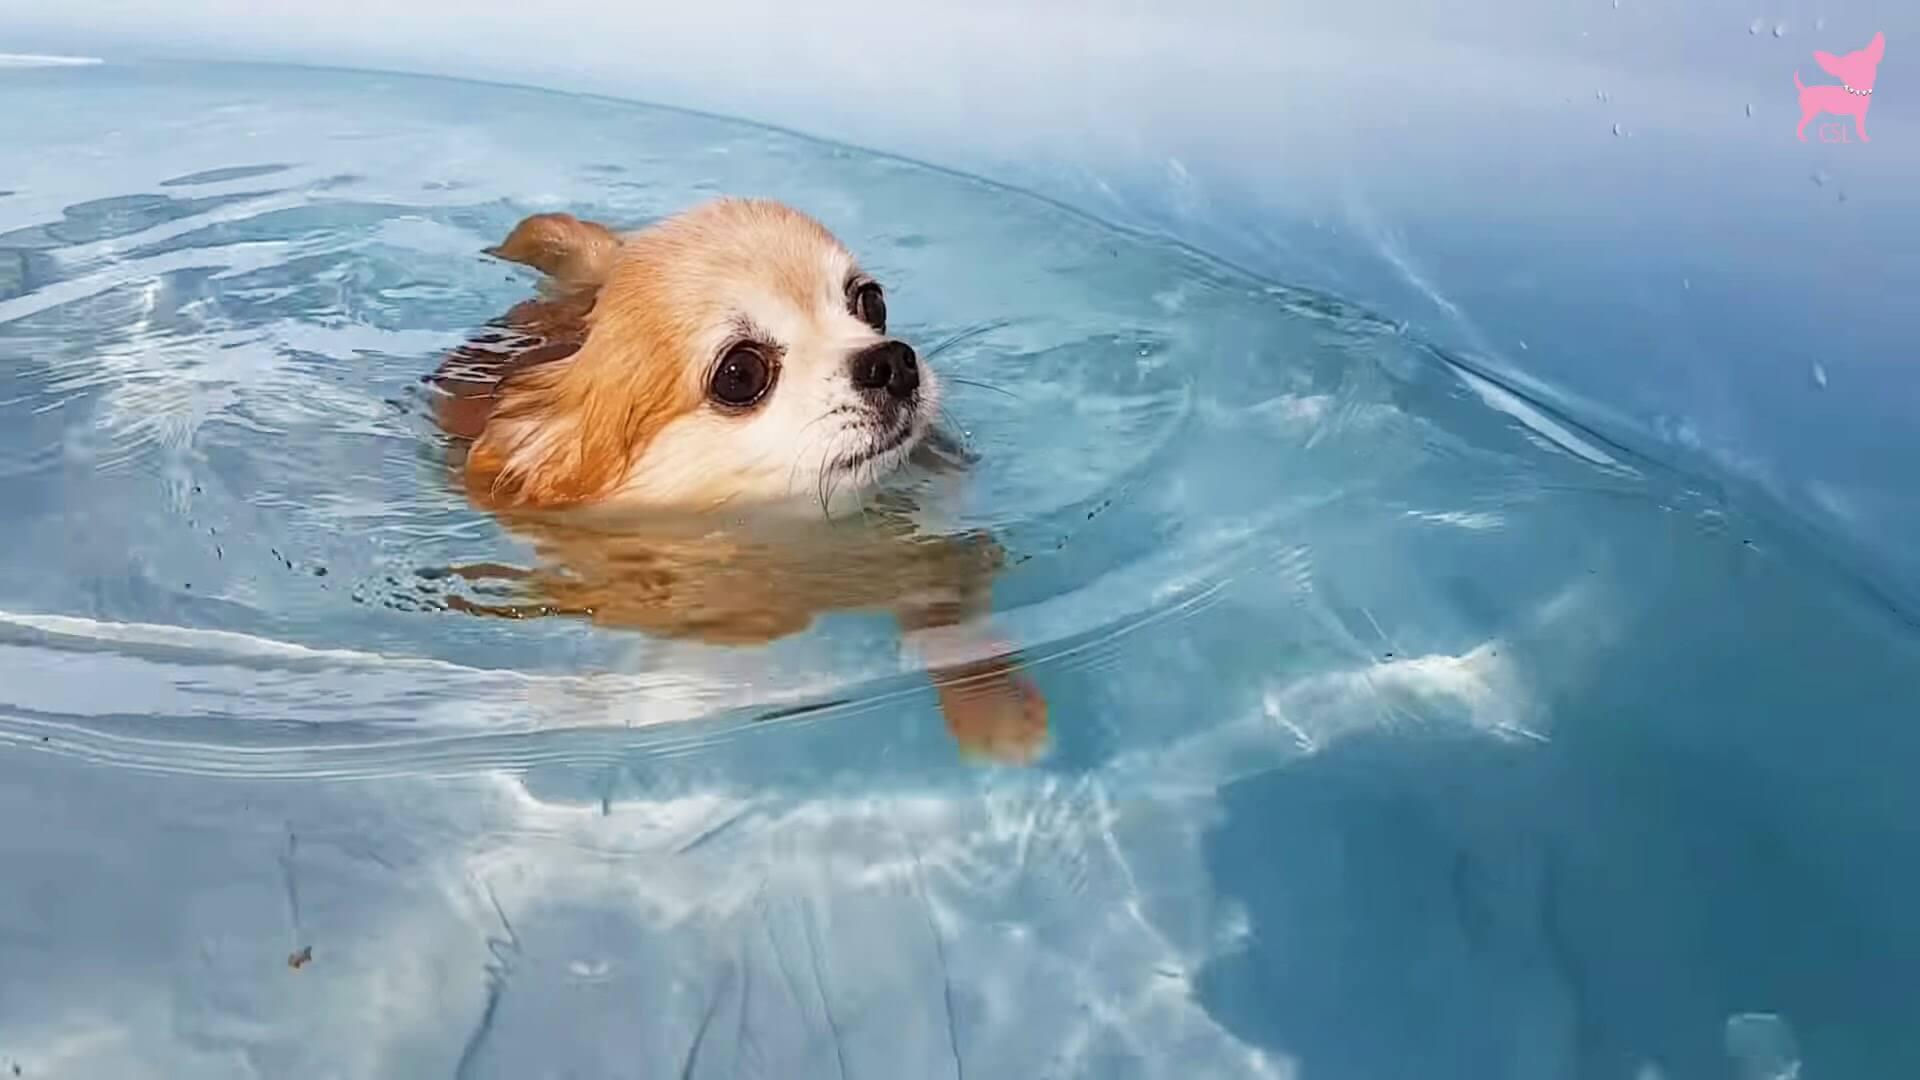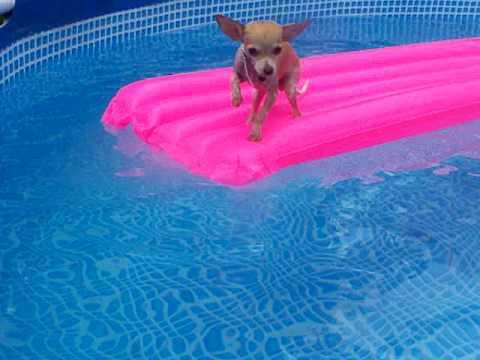The first image is the image on the left, the second image is the image on the right. For the images shown, is this caption "A dog is in a swimming pool with a floating device." true? Answer yes or no. Yes. The first image is the image on the left, the second image is the image on the right. For the images displayed, is the sentence "An image shows a small dog standing on top of a floating raft-type item." factually correct? Answer yes or no. Yes. 